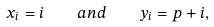<formula> <loc_0><loc_0><loc_500><loc_500>x _ { i } = i \quad a n d \quad y _ { i } = p + i ,</formula> 